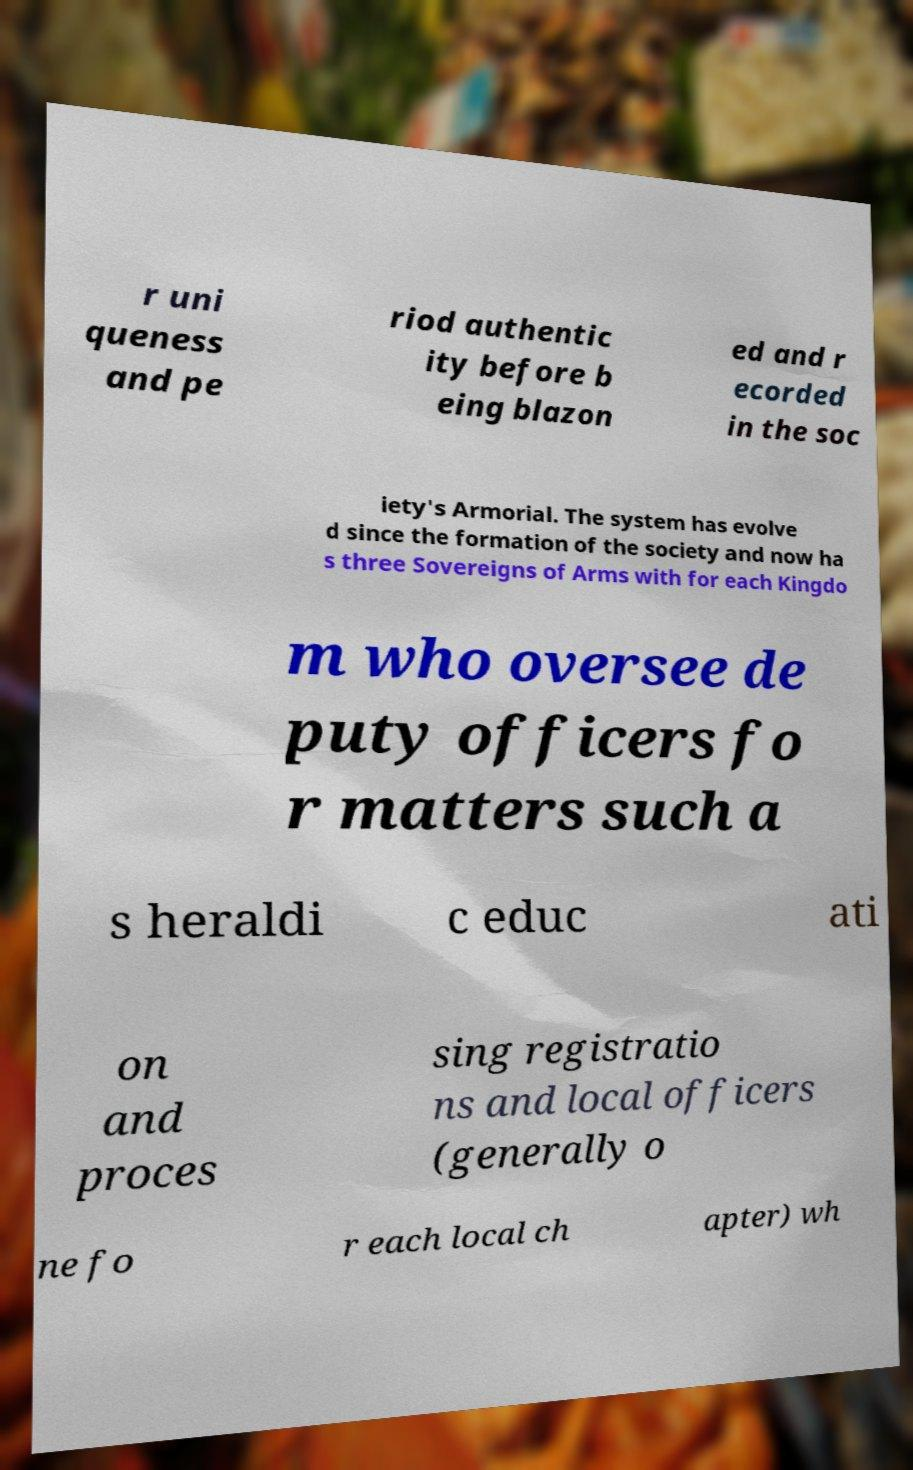Can you accurately transcribe the text from the provided image for me? r uni queness and pe riod authentic ity before b eing blazon ed and r ecorded in the soc iety's Armorial. The system has evolve d since the formation of the society and now ha s three Sovereigns of Arms with for each Kingdo m who oversee de puty officers fo r matters such a s heraldi c educ ati on and proces sing registratio ns and local officers (generally o ne fo r each local ch apter) wh 